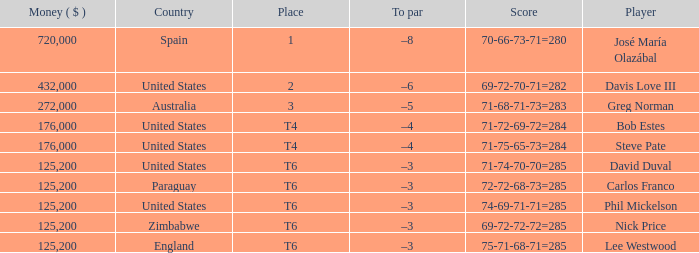Which Score has a Place of 3? 71-68-71-73=283. 